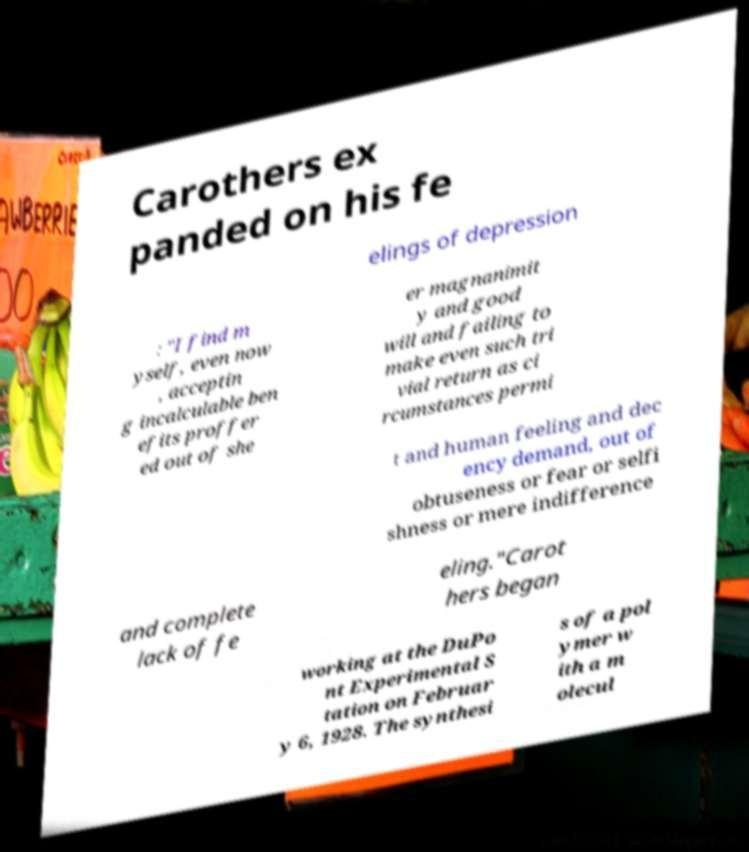Can you read and provide the text displayed in the image?This photo seems to have some interesting text. Can you extract and type it out for me? Carothers ex panded on his fe elings of depression : "I find m yself, even now , acceptin g incalculable ben efits proffer ed out of she er magnanimit y and good will and failing to make even such tri vial return as ci rcumstances permi t and human feeling and dec ency demand, out of obtuseness or fear or selfi shness or mere indifference and complete lack of fe eling."Carot hers began working at the DuPo nt Experimental S tation on Februar y 6, 1928. The synthesi s of a pol ymer w ith a m olecul 